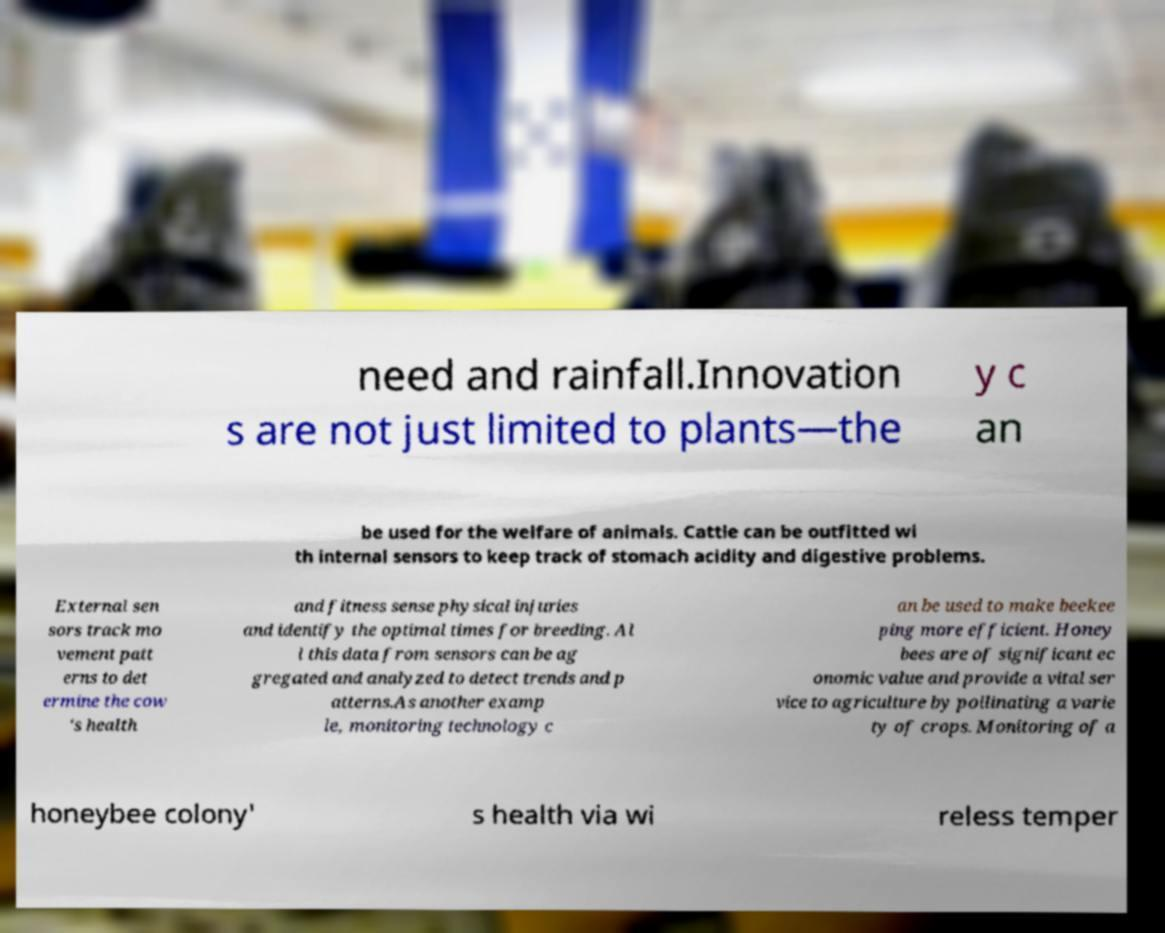Please read and relay the text visible in this image. What does it say? need and rainfall.Innovation s are not just limited to plants—the y c an be used for the welfare of animals. Cattle can be outfitted wi th internal sensors to keep track of stomach acidity and digestive problems. External sen sors track mo vement patt erns to det ermine the cow 's health and fitness sense physical injuries and identify the optimal times for breeding. Al l this data from sensors can be ag gregated and analyzed to detect trends and p atterns.As another examp le, monitoring technology c an be used to make beekee ping more efficient. Honey bees are of significant ec onomic value and provide a vital ser vice to agriculture by pollinating a varie ty of crops. Monitoring of a honeybee colony' s health via wi reless temper 